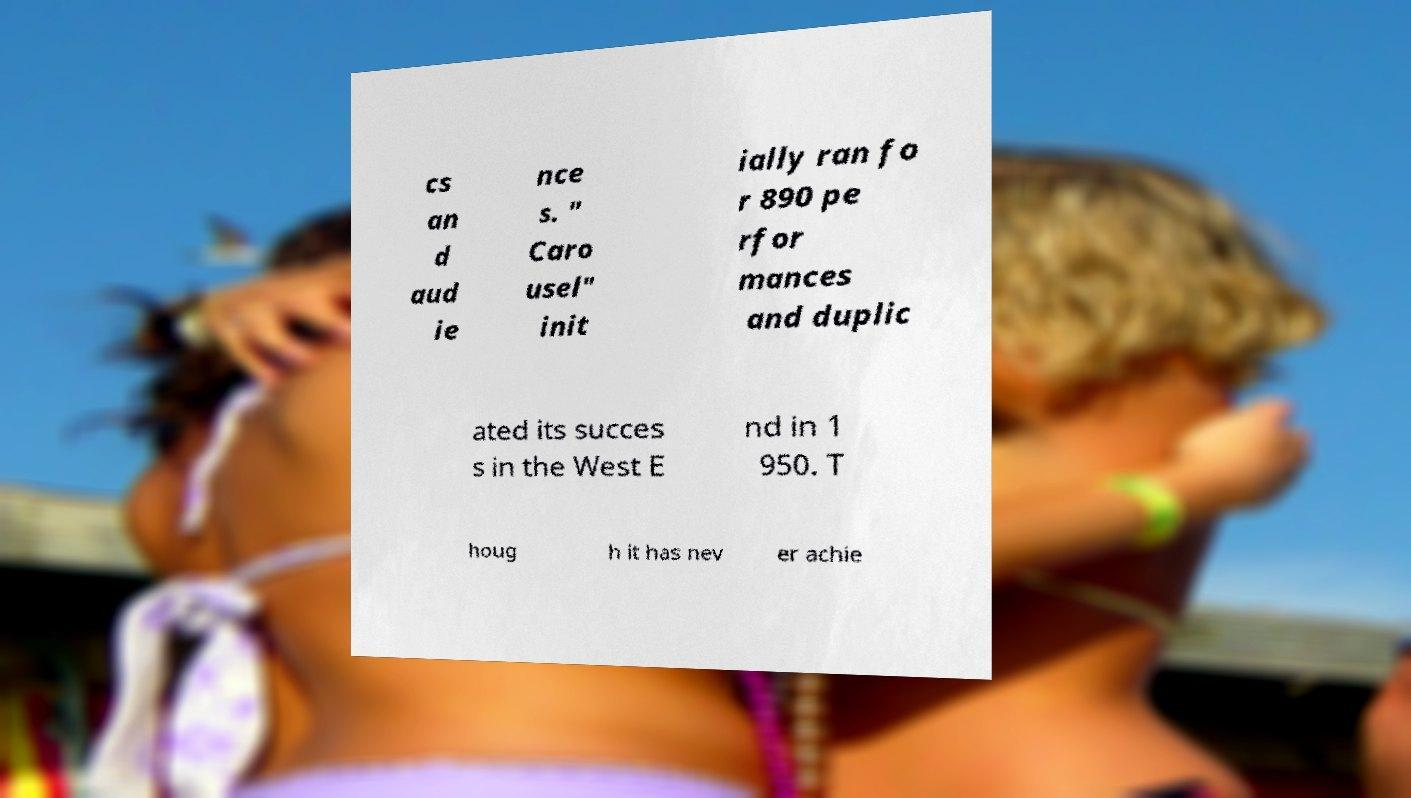Please read and relay the text visible in this image. What does it say? cs an d aud ie nce s. " Caro usel" init ially ran fo r 890 pe rfor mances and duplic ated its succes s in the West E nd in 1 950. T houg h it has nev er achie 